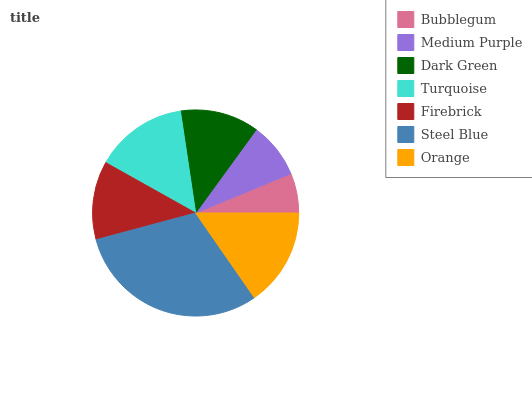Is Bubblegum the minimum?
Answer yes or no. Yes. Is Steel Blue the maximum?
Answer yes or no. Yes. Is Medium Purple the minimum?
Answer yes or no. No. Is Medium Purple the maximum?
Answer yes or no. No. Is Medium Purple greater than Bubblegum?
Answer yes or no. Yes. Is Bubblegum less than Medium Purple?
Answer yes or no. Yes. Is Bubblegum greater than Medium Purple?
Answer yes or no. No. Is Medium Purple less than Bubblegum?
Answer yes or no. No. Is Dark Green the high median?
Answer yes or no. Yes. Is Dark Green the low median?
Answer yes or no. Yes. Is Firebrick the high median?
Answer yes or no. No. Is Orange the low median?
Answer yes or no. No. 